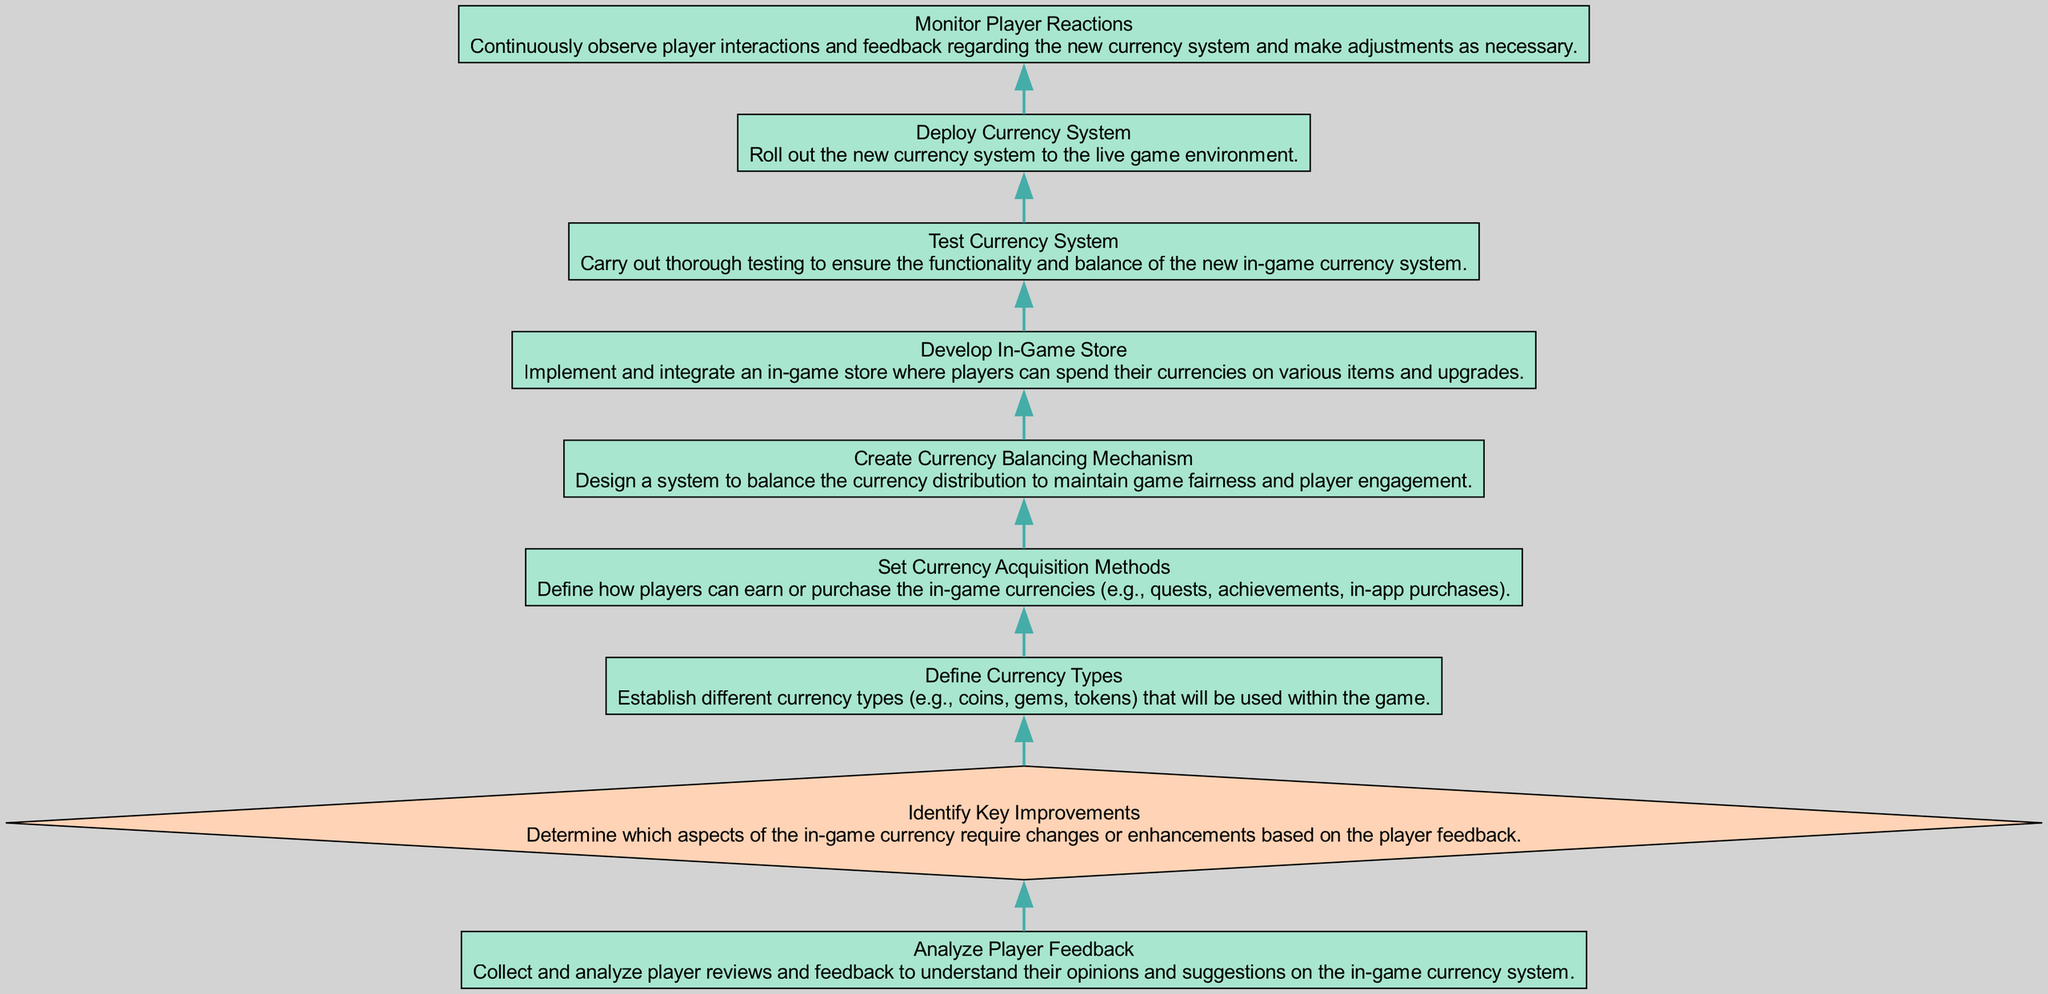What is the first step in the process? The first step in the diagram is "Analyze Player Feedback," which is the bottom node in the flow chart.
Answer: Analyze Player Feedback How many total nodes are in the diagram? The diagram includes 9 total nodes that represent the different steps in the in-game currency system implementation process.
Answer: 9 What is the last step before monitoring player reactions? The last step before monitoring player reactions is "Deploy Currency System," which directly precedes the monitoring phase in the flow chart.
Answer: Deploy Currency System What are the two types of nodes present in the diagram? The two types of nodes in the diagram are "process" nodes and "decision" nodes.
Answer: process and decision Which step involves defining how players earn currency? The step that involves defining how players earn currency is "Set Currency Acquisition Methods."
Answer: Set Currency Acquisition Methods What is the outcome of identifying key improvements? The outcome of identifying key improvements is to determine which aspects of the in-game currency require changes or enhancements.
Answer: Determine changes What is the relationship between creating currency balancing mechanism and deploying currency system? The relationship is sequential; "Create Currency Balancing Mechanism" must be completed before "Deploy Currency System," indicating that balancing is a prerequisite for deployment.
Answer: Sequential In which step do developers implement the in-game store? Developers implement the in-game store in the step "Develop In-Game Store."
Answer: Develop In-Game Store What is the primary purpose of the "Test Currency System" step? The primary purpose of the "Test Currency System" step is to ensure the functionality and balance of the new in-game currency system before it goes live.
Answer: Ensure functionality and balance 